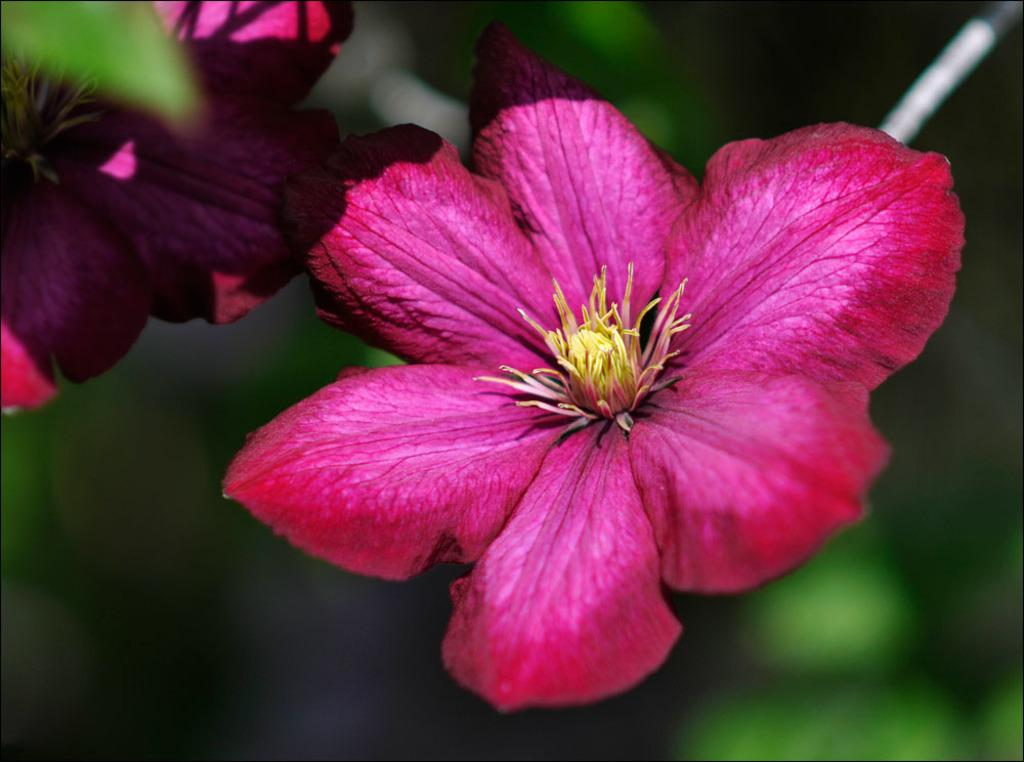What type of flowers can be seen in the image? There are pink color flowers in the image. Can you describe the background of the image? The background of the image is blurred. How many seats are visible in the image? There are no seats present in the image; it only features pink color flowers and a blurred background. 